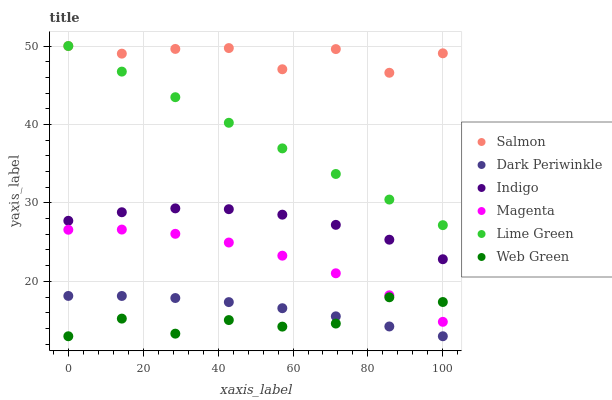Does Web Green have the minimum area under the curve?
Answer yes or no. Yes. Does Salmon have the maximum area under the curve?
Answer yes or no. Yes. Does Salmon have the minimum area under the curve?
Answer yes or no. No. Does Web Green have the maximum area under the curve?
Answer yes or no. No. Is Lime Green the smoothest?
Answer yes or no. Yes. Is Salmon the roughest?
Answer yes or no. Yes. Is Web Green the smoothest?
Answer yes or no. No. Is Web Green the roughest?
Answer yes or no. No. Does Web Green have the lowest value?
Answer yes or no. Yes. Does Salmon have the lowest value?
Answer yes or no. No. Does Lime Green have the highest value?
Answer yes or no. Yes. Does Web Green have the highest value?
Answer yes or no. No. Is Magenta less than Lime Green?
Answer yes or no. Yes. Is Lime Green greater than Dark Periwinkle?
Answer yes or no. Yes. Does Lime Green intersect Salmon?
Answer yes or no. Yes. Is Lime Green less than Salmon?
Answer yes or no. No. Is Lime Green greater than Salmon?
Answer yes or no. No. Does Magenta intersect Lime Green?
Answer yes or no. No. 